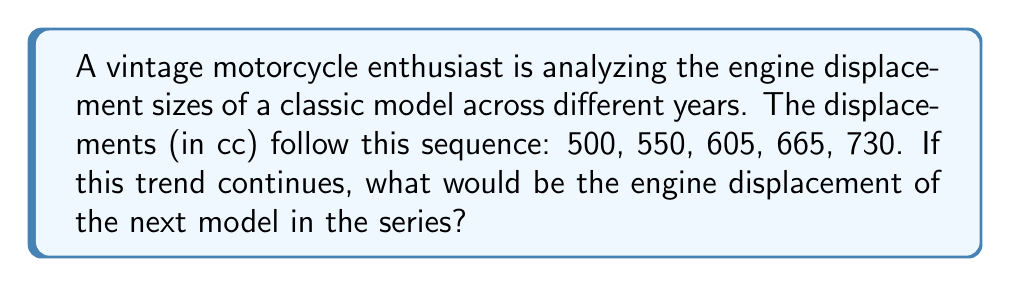Give your solution to this math problem. To solve this problem, we need to analyze the progression of the engine displacement sizes:

1. First, let's calculate the differences between consecutive terms:
   $550 - 500 = 50$
   $605 - 550 = 55$
   $665 - 605 = 60$
   $730 - 665 = 65$

2. We can see that the difference is increasing by 5 cc each time:
   $55 - 50 = 5$
   $60 - 55 = 5$
   $65 - 60 = 5$

3. This suggests an arithmetic sequence of second order, where the difference between differences is constant.

4. To find the next term, we need to add the next difference to the last term:
   The next difference will be: $65 + 5 = 70$

5. Therefore, the next term in the sequence will be:
   $730 + 70 = 800$

Thus, if this trend continues, the engine displacement of the next model in the series would be 800 cc.
Answer: 800 cc 